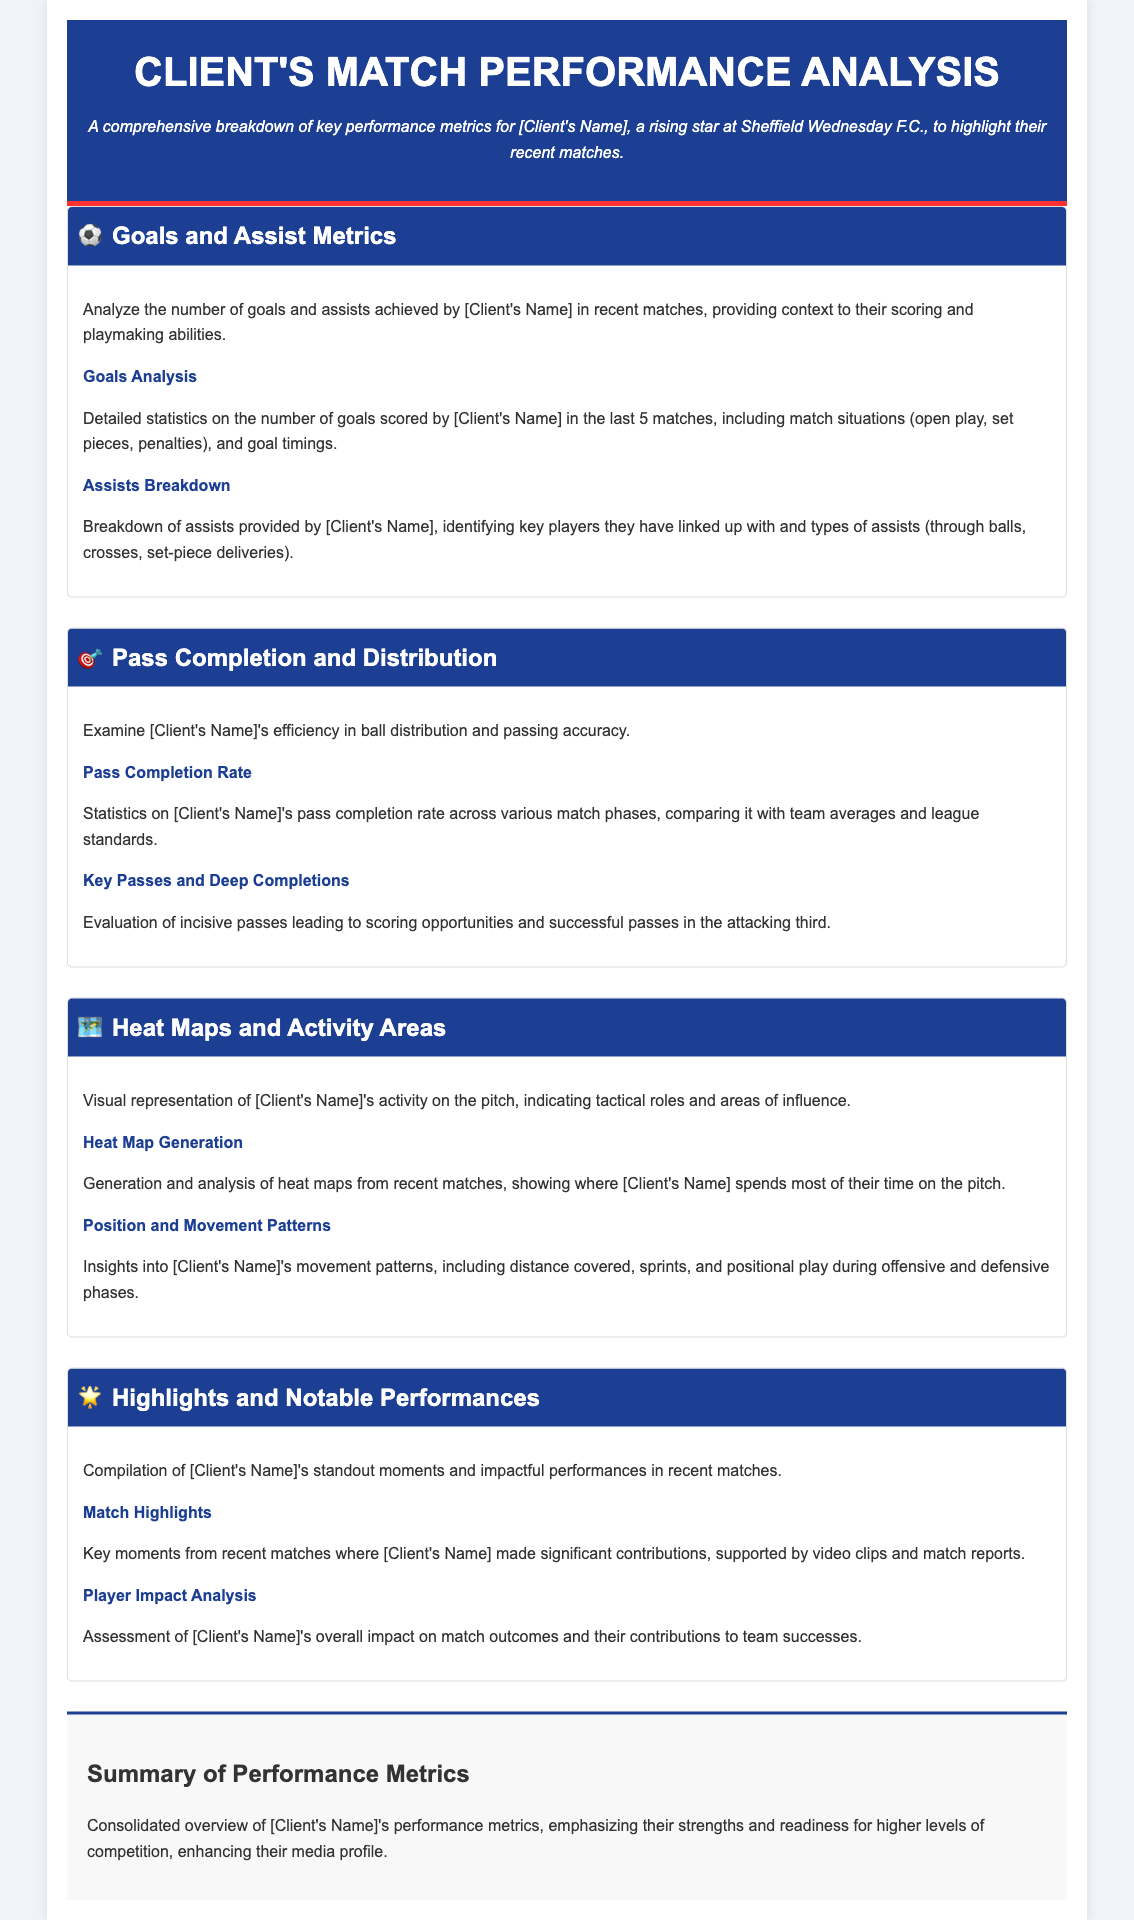what is the main focus of the document? The document provides a comprehensive breakdown of key performance metrics for a rising star at Sheffield Wednesday F.C.
Answer: match performance analysis how many topics are covered in the Goals and Assist Metrics module? The document mentions two topics under the Goals and Assist Metrics module.
Answer: 2 what are the two key player statistics analyzed in the Pass Completion and Distribution module? The two key statistics analyzed are Pass Completion Rate and Key Passes and Deep Completions.
Answer: Pass Completion Rate, Key Passes and Deep Completions what does the Heat Map Generation topic focus on? The Heat Map Generation topic focuses on generating and analyzing heat maps from recent matches.
Answer: generating and analyzing heat maps how many standout moments are compiled in the Highlights and Notable Performances module? The Highlights and Notable Performances module contains two topics, thus implying multiple standout moments.
Answer: at least 2 what is emphasized in the Summary of Performance Metrics? The Summary emphasizes the strengths and readiness of the player for higher levels of competition.
Answer: strengths and readiness for higher levels of competition which color theme is used for the header? The header utilizes a blue color theme for its background.
Answer: blue who is the rising star mentioned in the document? The document refers to the rising star generically as [Client's Name].
Answer: [Client's Name] 